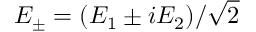<formula> <loc_0><loc_0><loc_500><loc_500>E _ { \pm } = ( E _ { 1 } \pm i E _ { 2 } ) / \sqrt { 2 }</formula> 